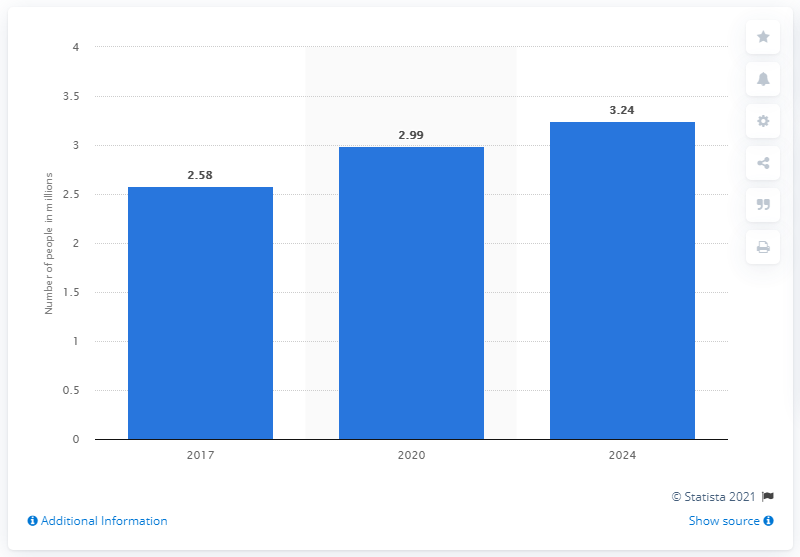Outline some significant characteristics in this image. By 2024, it is projected that there will be approximately 3.24 million patients suffering from mental disorders in Indonesia. 